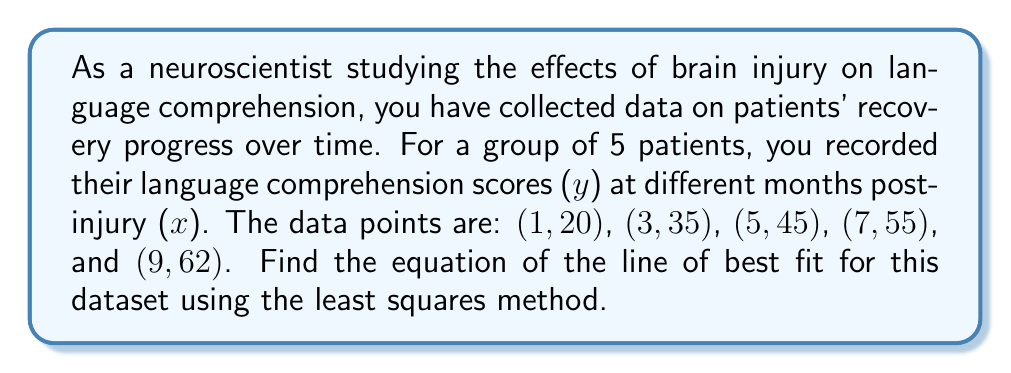What is the answer to this math problem? To find the line of best fit using the least squares method, we need to calculate the slope (m) and y-intercept (b) of the line y = mx + b.

Step 1: Calculate the means of x and y.
$\bar{x} = \frac{1+3+5+7+9}{5} = 5$
$\bar{y} = \frac{20+35+45+55+62}{5} = 43.4$

Step 2: Calculate $\sum(x - \bar{x})(y - \bar{y})$ and $\sum(x - \bar{x})^2$.
$\sum(x - \bar{x})(y - \bar{y}) = (-4)(-23.4) + (-2)(-8.4) + (0)(1.6) + (2)(11.6) + (4)(18.6) = 184$
$\sum(x - \bar{x})^2 = (-4)^2 + (-2)^2 + (0)^2 + (2)^2 + (4)^2 = 40$

Step 3: Calculate the slope (m).
$m = \frac{\sum(x - \bar{x})(y - \bar{y})}{\sum(x - \bar{x})^2} = \frac{184}{40} = 4.6$

Step 4: Calculate the y-intercept (b) using the point $(\bar{x}, \bar{y})$.
$b = \bar{y} - m\bar{x} = 43.4 - 4.6(5) = 20.4$

Step 5: Write the equation of the line of best fit.
$y = 4.6x + 20.4$
Answer: $y = 4.6x + 20.4$ 